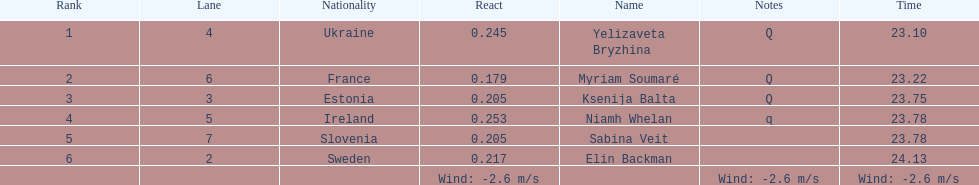Who finished after sabina veit? Elin Backman. 